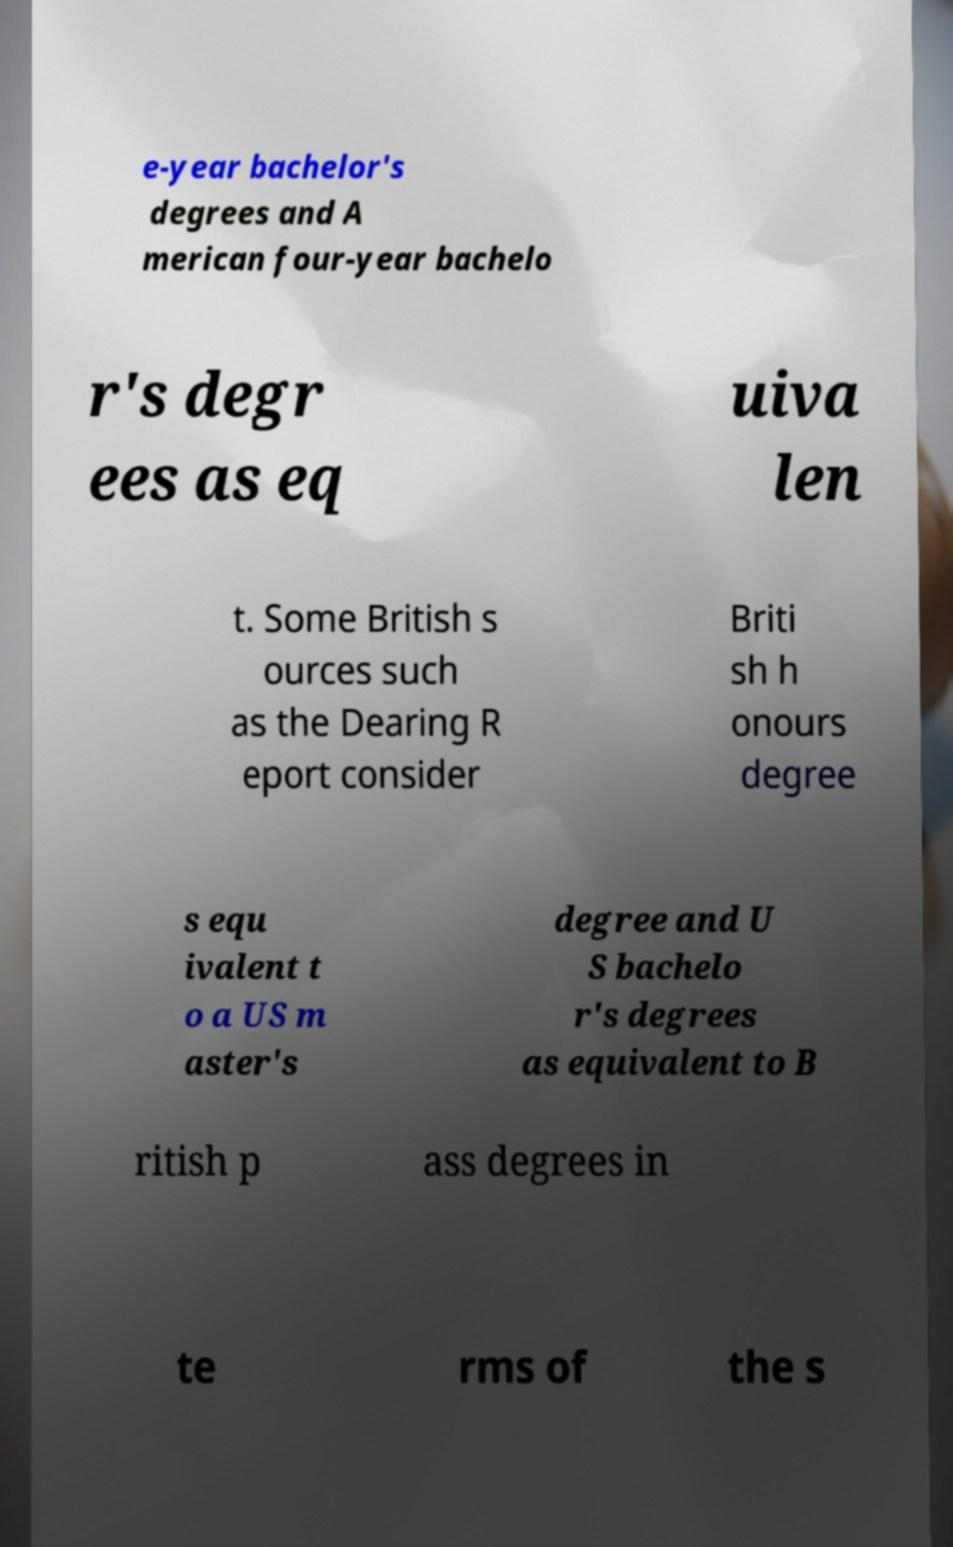Please read and relay the text visible in this image. What does it say? e-year bachelor's degrees and A merican four-year bachelo r's degr ees as eq uiva len t. Some British s ources such as the Dearing R eport consider Briti sh h onours degree s equ ivalent t o a US m aster's degree and U S bachelo r's degrees as equivalent to B ritish p ass degrees in te rms of the s 